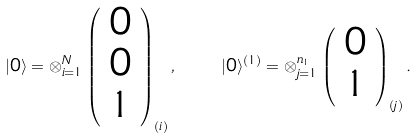<formula> <loc_0><loc_0><loc_500><loc_500>| 0 \rangle = \otimes _ { i = 1 } ^ { N } \left ( \begin{array} { c } 0 \\ 0 \\ 1 \end{array} \right ) _ { ( i ) } , \quad | 0 \rangle ^ { ( 1 ) } = \otimes _ { j = 1 } ^ { n _ { 1 } } \left ( \begin{array} { c } 0 \\ 1 \end{array} \right ) _ { ( j ) } .</formula> 